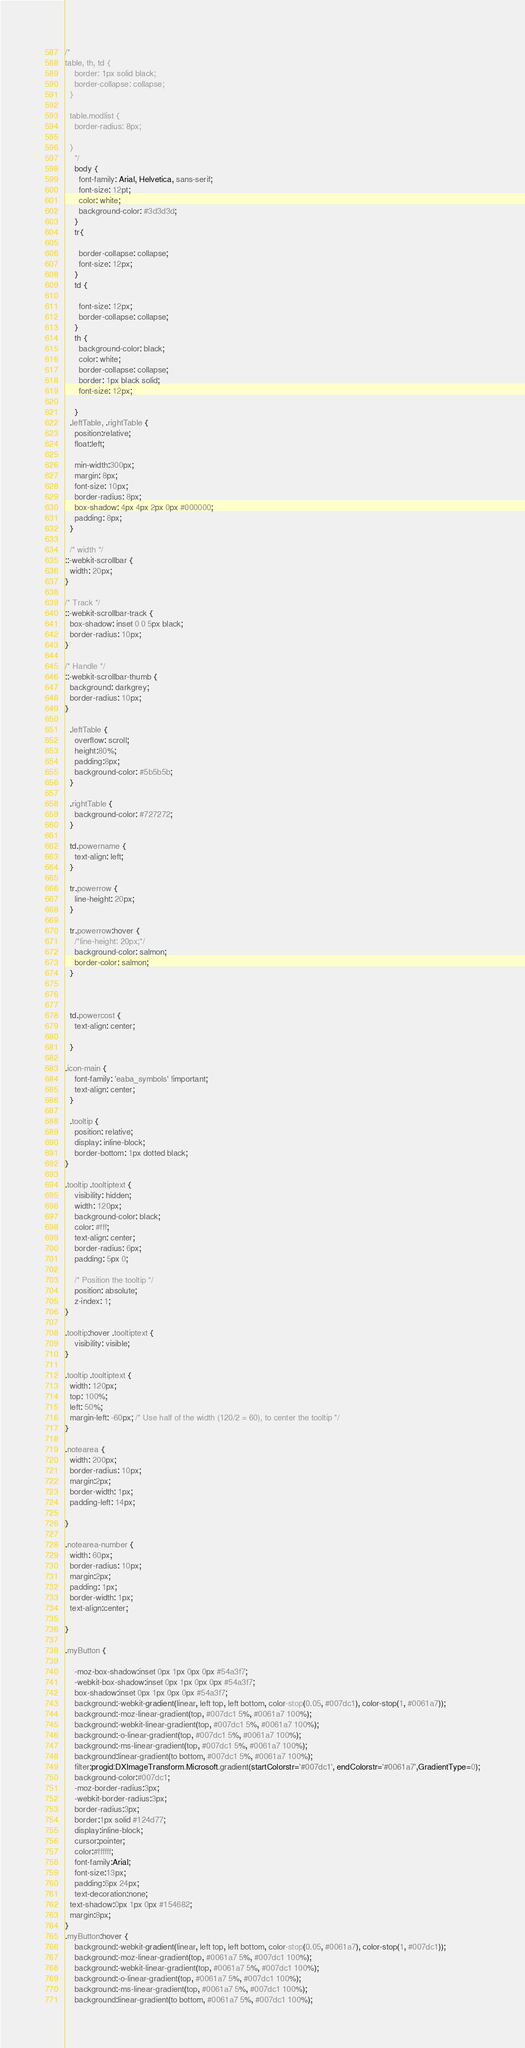<code> <loc_0><loc_0><loc_500><loc_500><_CSS_>/*
table, th, td {
    border: 1px solid black;
    border-collapse: collapse;
  }
  
  table.modlist {
    border-radius: 8px;
    
  }
    */
    body {
      font-family: Arial, Helvetica, sans-serif;
      font-size: 12pt; 
      color: white;
      background-color: #3d3d3d;
    }
    tr{

      border-collapse: collapse;
      font-size: 12px;
    }
    td {

      font-size: 12px;
      border-collapse: collapse;
    }
    th {
      background-color: black;
      color: white;
      border-collapse: collapse;
      border: 1px black solid;
      font-size: 12px;

    }
  .leftTable, .rightTable {
    position:relative;
    float:left;
    
    min-width:300px;
    margin: 8px;
    font-size: 10px;
    border-radius: 8px;
    box-shadow: 4px 4px 2px 0px #000000;
    padding: 8px;
  }

  /* width */
::-webkit-scrollbar {
  width: 20px;
}

/* Track */
::-webkit-scrollbar-track {
  box-shadow: inset 0 0 5px black; 
  border-radius: 10px;
}

/* Handle */
::-webkit-scrollbar-thumb {
  background: darkgrey; 
  border-radius: 10px;
}

  .leftTable {
    overflow: scroll;
    height:80%;
    padding:8px;
    background-color: #5b5b5b;
  }

  .rightTable {
    background-color: #727272;
  }

  td.powername {
    text-align: left;
  }

  tr.powerrow {
    line-height: 20px;
  }

  tr.powerrow:hover {
    /*line-height: 20px;*/
    background-color: salmon;
    border-color: salmon;
  }



  td.powercost {
    text-align: center;

  }

.icon-main {
    font-family: 'eaba_symbols' !important;
    text-align: center;
  }

  .tooltip {
    position: relative;
    display: inline-block;
    border-bottom: 1px dotted black;
}

.tooltip .tooltiptext {
    visibility: hidden;
    width: 120px;
    background-color: black;
    color: #fff;
    text-align: center;
    border-radius: 6px;
    padding: 5px 0;

    /* Position the tooltip */
    position: absolute;
    z-index: 1;
}

.tooltip:hover .tooltiptext {
    visibility: visible;
}

.tooltip .tooltiptext {
  width: 120px;
  top: 100%;
  left: 50%; 
  margin-left: -60px; /* Use half of the width (120/2 = 60), to center the tooltip */
}

.notearea {
  width: 200px;
  border-radius: 10px;
  margin:2px;
  border-width: 1px;
  padding-left: 14px;

}

.notearea-number {
  width: 60px;
  border-radius: 10px;
  margin:2px;
  padding: 1px;
  border-width: 1px;
  text-align:center;

}

.myButton {
  
	-moz-box-shadow:inset 0px 1px 0px 0px #54a3f7;
	-webkit-box-shadow:inset 0px 1px 0px 0px #54a3f7;
	box-shadow:inset 0px 1px 0px 0px #54a3f7;
	background:-webkit-gradient(linear, left top, left bottom, color-stop(0.05, #007dc1), color-stop(1, #0061a7));
	background:-moz-linear-gradient(top, #007dc1 5%, #0061a7 100%);
	background:-webkit-linear-gradient(top, #007dc1 5%, #0061a7 100%);
	background:-o-linear-gradient(top, #007dc1 5%, #0061a7 100%);
	background:-ms-linear-gradient(top, #007dc1 5%, #0061a7 100%);
	background:linear-gradient(to bottom, #007dc1 5%, #0061a7 100%);
	filter:progid:DXImageTransform.Microsoft.gradient(startColorstr='#007dc1', endColorstr='#0061a7',GradientType=0);
	background-color:#007dc1;
	-moz-border-radius:3px;
	-webkit-border-radius:3px;
	border-radius:3px;
	border:1px solid #124d77;
	display:inline-block;
	cursor:pointer;
	color:#ffffff;
	font-family:Arial;
	font-size:13px;
	padding:6px 24px;
	text-decoration:none;
  text-shadow:0px 1px 0px #154682;
  margin:8px;
}
.myButton:hover {
	background:-webkit-gradient(linear, left top, left bottom, color-stop(0.05, #0061a7), color-stop(1, #007dc1));
	background:-moz-linear-gradient(top, #0061a7 5%, #007dc1 100%);
	background:-webkit-linear-gradient(top, #0061a7 5%, #007dc1 100%);
	background:-o-linear-gradient(top, #0061a7 5%, #007dc1 100%);
	background:-ms-linear-gradient(top, #0061a7 5%, #007dc1 100%);
	background:linear-gradient(to bottom, #0061a7 5%, #007dc1 100%);</code> 